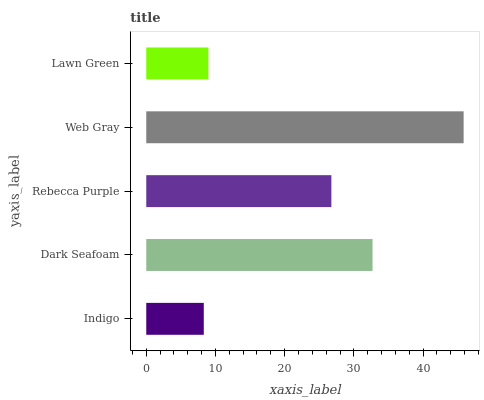Is Indigo the minimum?
Answer yes or no. Yes. Is Web Gray the maximum?
Answer yes or no. Yes. Is Dark Seafoam the minimum?
Answer yes or no. No. Is Dark Seafoam the maximum?
Answer yes or no. No. Is Dark Seafoam greater than Indigo?
Answer yes or no. Yes. Is Indigo less than Dark Seafoam?
Answer yes or no. Yes. Is Indigo greater than Dark Seafoam?
Answer yes or no. No. Is Dark Seafoam less than Indigo?
Answer yes or no. No. Is Rebecca Purple the high median?
Answer yes or no. Yes. Is Rebecca Purple the low median?
Answer yes or no. Yes. Is Lawn Green the high median?
Answer yes or no. No. Is Lawn Green the low median?
Answer yes or no. No. 